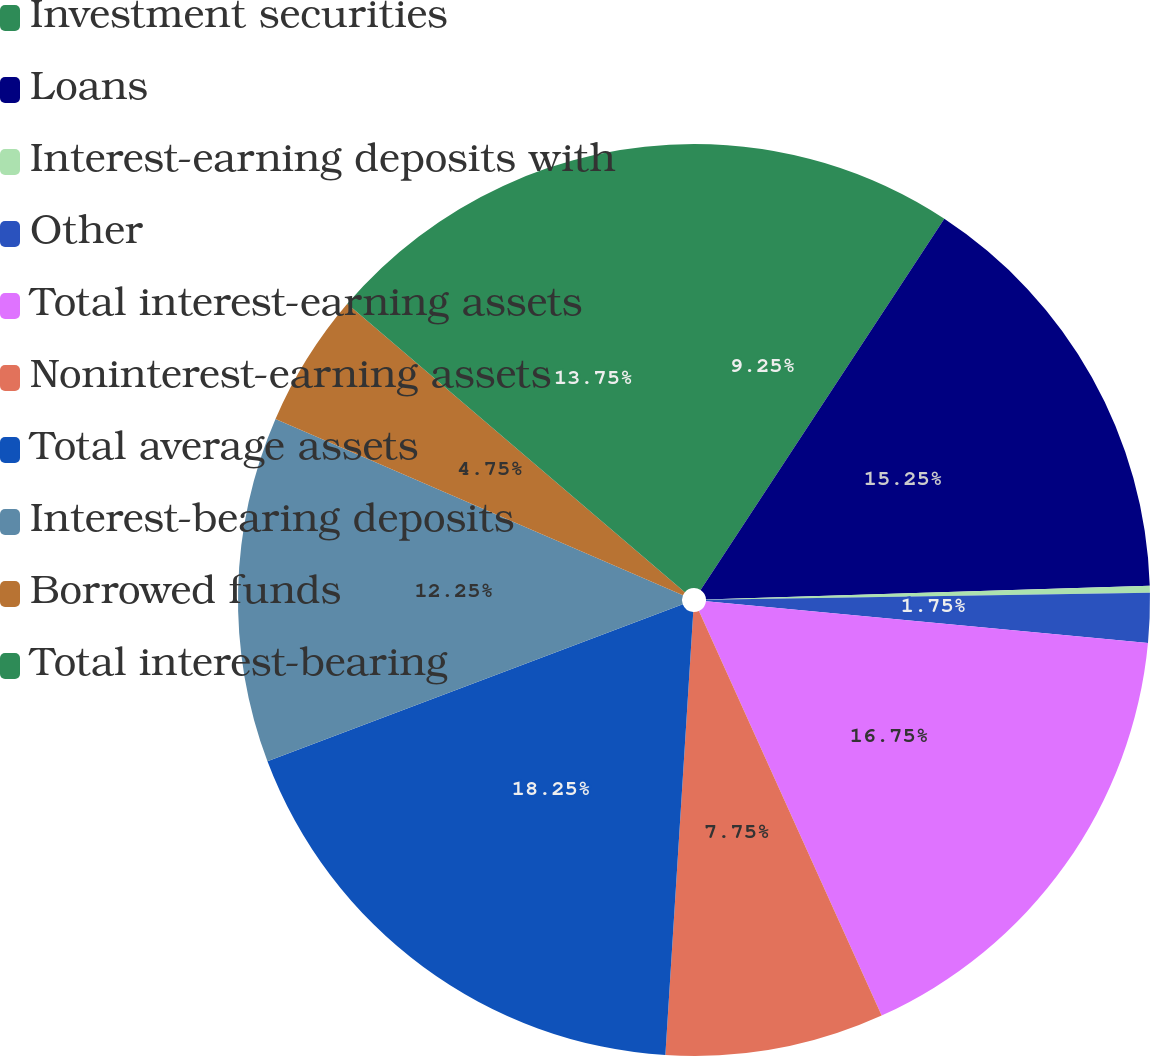<chart> <loc_0><loc_0><loc_500><loc_500><pie_chart><fcel>Investment securities<fcel>Loans<fcel>Interest-earning deposits with<fcel>Other<fcel>Total interest-earning assets<fcel>Noninterest-earning assets<fcel>Total average assets<fcel>Interest-bearing deposits<fcel>Borrowed funds<fcel>Total interest-bearing<nl><fcel>9.25%<fcel>15.25%<fcel>0.25%<fcel>1.75%<fcel>16.75%<fcel>7.75%<fcel>18.25%<fcel>12.25%<fcel>4.75%<fcel>13.75%<nl></chart> 